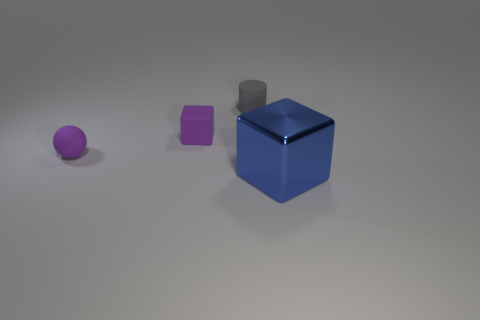Add 2 brown rubber objects. How many objects exist? 6 Subtract all blue blocks. How many blocks are left? 1 Subtract all cylinders. How many objects are left? 3 Subtract 1 cylinders. How many cylinders are left? 0 Add 4 large metallic blocks. How many large metallic blocks exist? 5 Subtract 1 purple blocks. How many objects are left? 3 Subtract all cyan spheres. Subtract all yellow cubes. How many spheres are left? 1 Subtract all brown balls. How many blue cubes are left? 1 Subtract all small purple cylinders. Subtract all tiny gray things. How many objects are left? 3 Add 4 purple rubber blocks. How many purple rubber blocks are left? 5 